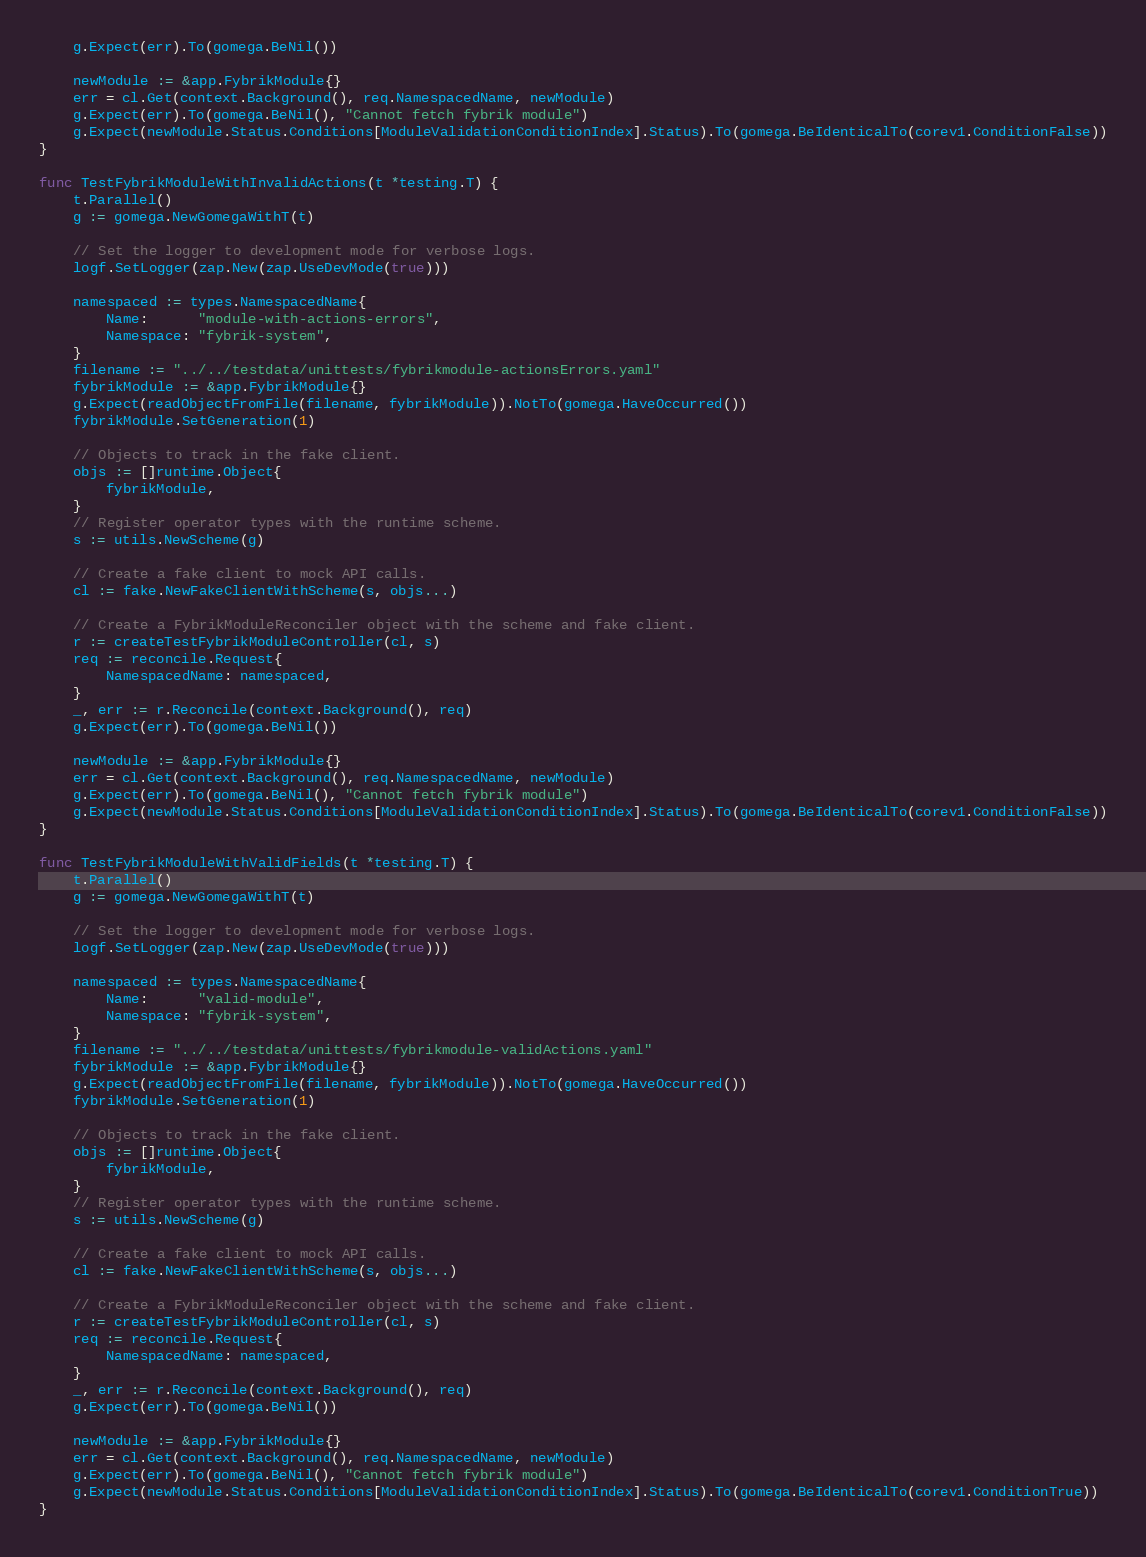<code> <loc_0><loc_0><loc_500><loc_500><_Go_>	g.Expect(err).To(gomega.BeNil())

	newModule := &app.FybrikModule{}
	err = cl.Get(context.Background(), req.NamespacedName, newModule)
	g.Expect(err).To(gomega.BeNil(), "Cannot fetch fybrik module")
	g.Expect(newModule.Status.Conditions[ModuleValidationConditionIndex].Status).To(gomega.BeIdenticalTo(corev1.ConditionFalse))
}

func TestFybrikModuleWithInvalidActions(t *testing.T) {
	t.Parallel()
	g := gomega.NewGomegaWithT(t)

	// Set the logger to development mode for verbose logs.
	logf.SetLogger(zap.New(zap.UseDevMode(true)))

	namespaced := types.NamespacedName{
		Name:      "module-with-actions-errors",
		Namespace: "fybrik-system",
	}
	filename := "../../testdata/unittests/fybrikmodule-actionsErrors.yaml"
	fybrikModule := &app.FybrikModule{}
	g.Expect(readObjectFromFile(filename, fybrikModule)).NotTo(gomega.HaveOccurred())
	fybrikModule.SetGeneration(1)

	// Objects to track in the fake client.
	objs := []runtime.Object{
		fybrikModule,
	}
	// Register operator types with the runtime scheme.
	s := utils.NewScheme(g)

	// Create a fake client to mock API calls.
	cl := fake.NewFakeClientWithScheme(s, objs...)

	// Create a FybrikModuleReconciler object with the scheme and fake client.
	r := createTestFybrikModuleController(cl, s)
	req := reconcile.Request{
		NamespacedName: namespaced,
	}
	_, err := r.Reconcile(context.Background(), req)
	g.Expect(err).To(gomega.BeNil())

	newModule := &app.FybrikModule{}
	err = cl.Get(context.Background(), req.NamespacedName, newModule)
	g.Expect(err).To(gomega.BeNil(), "Cannot fetch fybrik module")
	g.Expect(newModule.Status.Conditions[ModuleValidationConditionIndex].Status).To(gomega.BeIdenticalTo(corev1.ConditionFalse))
}

func TestFybrikModuleWithValidFields(t *testing.T) {
	t.Parallel()
	g := gomega.NewGomegaWithT(t)

	// Set the logger to development mode for verbose logs.
	logf.SetLogger(zap.New(zap.UseDevMode(true)))

	namespaced := types.NamespacedName{
		Name:      "valid-module",
		Namespace: "fybrik-system",
	}
	filename := "../../testdata/unittests/fybrikmodule-validActions.yaml"
	fybrikModule := &app.FybrikModule{}
	g.Expect(readObjectFromFile(filename, fybrikModule)).NotTo(gomega.HaveOccurred())
	fybrikModule.SetGeneration(1)

	// Objects to track in the fake client.
	objs := []runtime.Object{
		fybrikModule,
	}
	// Register operator types with the runtime scheme.
	s := utils.NewScheme(g)

	// Create a fake client to mock API calls.
	cl := fake.NewFakeClientWithScheme(s, objs...)

	// Create a FybrikModuleReconciler object with the scheme and fake client.
	r := createTestFybrikModuleController(cl, s)
	req := reconcile.Request{
		NamespacedName: namespaced,
	}
	_, err := r.Reconcile(context.Background(), req)
	g.Expect(err).To(gomega.BeNil())

	newModule := &app.FybrikModule{}
	err = cl.Get(context.Background(), req.NamespacedName, newModule)
	g.Expect(err).To(gomega.BeNil(), "Cannot fetch fybrik module")
	g.Expect(newModule.Status.Conditions[ModuleValidationConditionIndex].Status).To(gomega.BeIdenticalTo(corev1.ConditionTrue))
}
</code> 